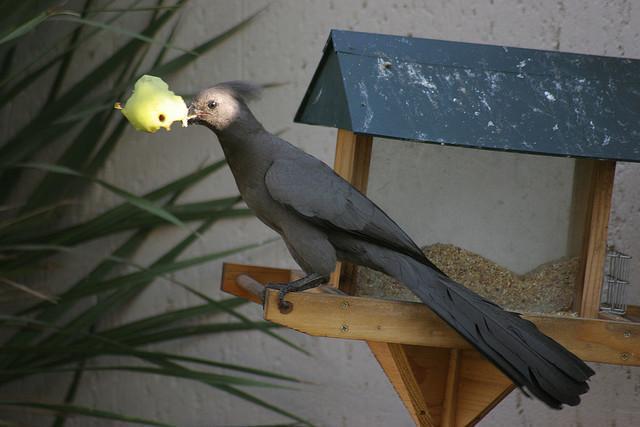How many birds are there?
Give a very brief answer. 1. How many birds are in the picture?
Give a very brief answer. 1. How many people are wearing red?
Give a very brief answer. 0. 